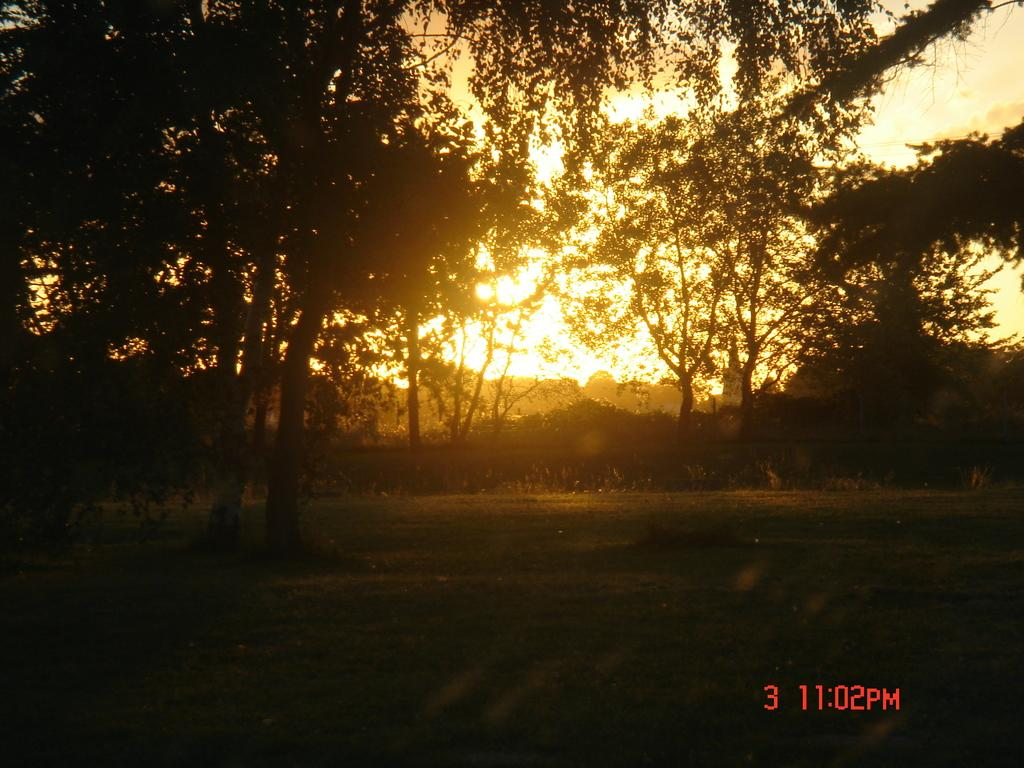What type of terrain is shown in the image? The image depicts a grassy land. What natural features can be seen in the image? There are many trees and plants in the image. What part of the natural environment is visible in the image? The sky is visible in the image. What type of square is present in the image? There is no square present in the image; it features a grassy land with trees, plants, and a visible sky. What type of badge can be seen on the trees in the image? There are no badges present on the trees in the image; it simply shows trees and plants in a grassy land. 